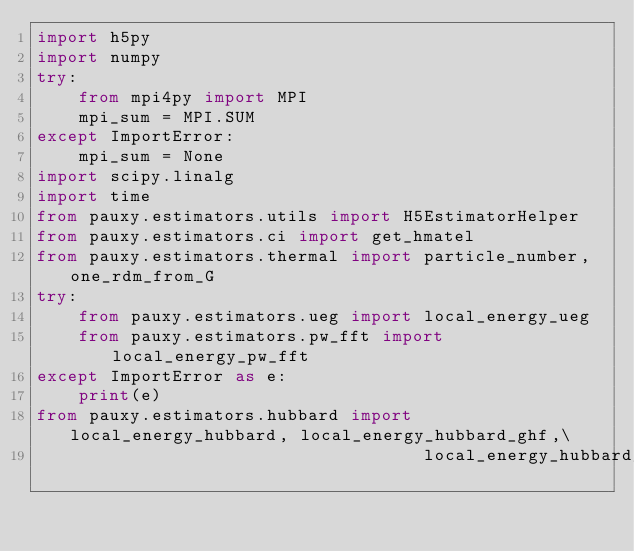<code> <loc_0><loc_0><loc_500><loc_500><_Python_>import h5py
import numpy
try:
    from mpi4py import MPI
    mpi_sum = MPI.SUM
except ImportError:
    mpi_sum = None
import scipy.linalg
import time
from pauxy.estimators.utils import H5EstimatorHelper
from pauxy.estimators.ci import get_hmatel
from pauxy.estimators.thermal import particle_number, one_rdm_from_G
try:
    from pauxy.estimators.ueg import local_energy_ueg
    from pauxy.estimators.pw_fft import local_energy_pw_fft
except ImportError as e:
    print(e)
from pauxy.estimators.hubbard import local_energy_hubbard, local_energy_hubbard_ghf,\
                                     local_energy_hubbard_holstein</code> 